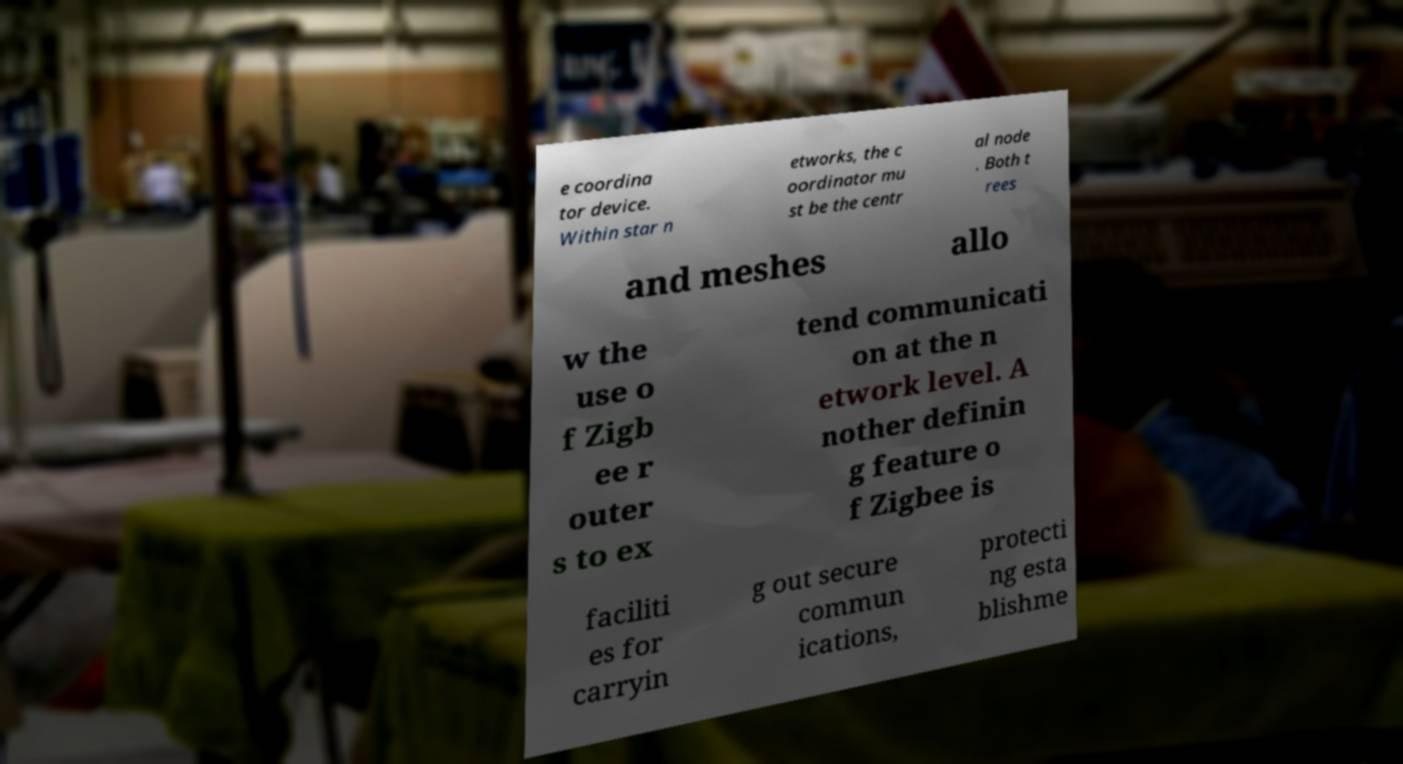Please read and relay the text visible in this image. What does it say? e coordina tor device. Within star n etworks, the c oordinator mu st be the centr al node . Both t rees and meshes allo w the use o f Zigb ee r outer s to ex tend communicati on at the n etwork level. A nother definin g feature o f Zigbee is faciliti es for carryin g out secure commun ications, protecti ng esta blishme 